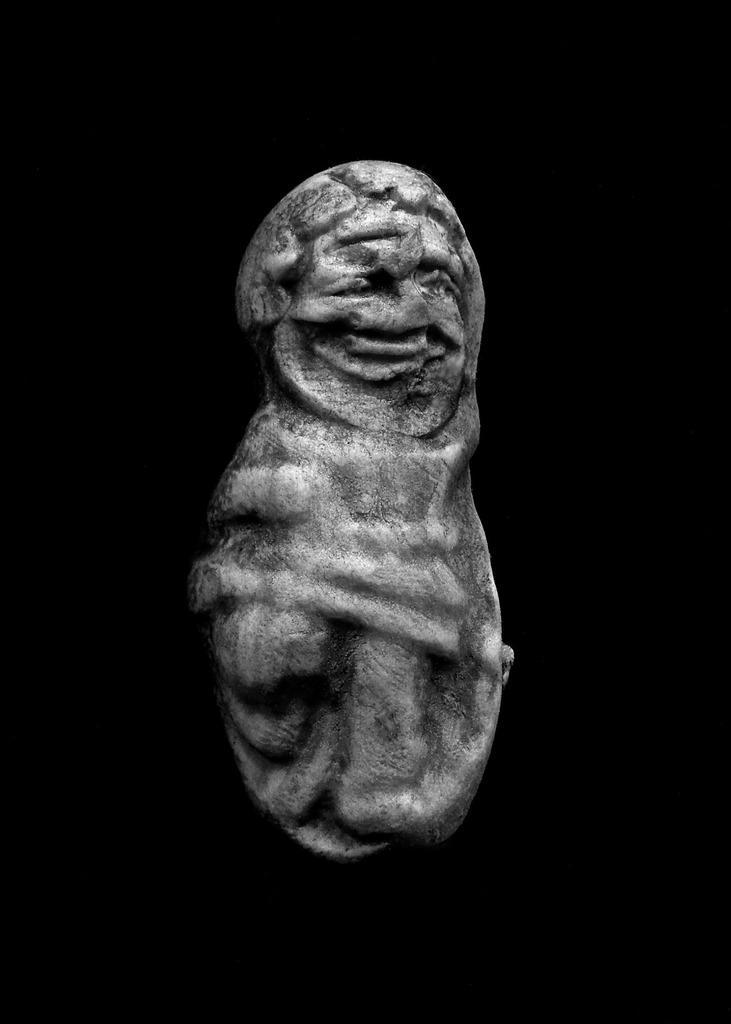Can you describe this image briefly? In this image we can see carving on the stone and the background of the image is black. 